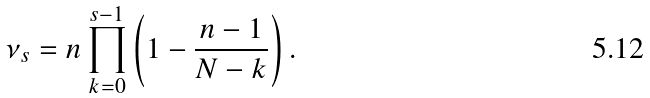Convert formula to latex. <formula><loc_0><loc_0><loc_500><loc_500>\nu _ { s } = n \prod _ { k = 0 } ^ { s - 1 } \left ( 1 - \frac { n - 1 } { N - k } \right ) .</formula> 